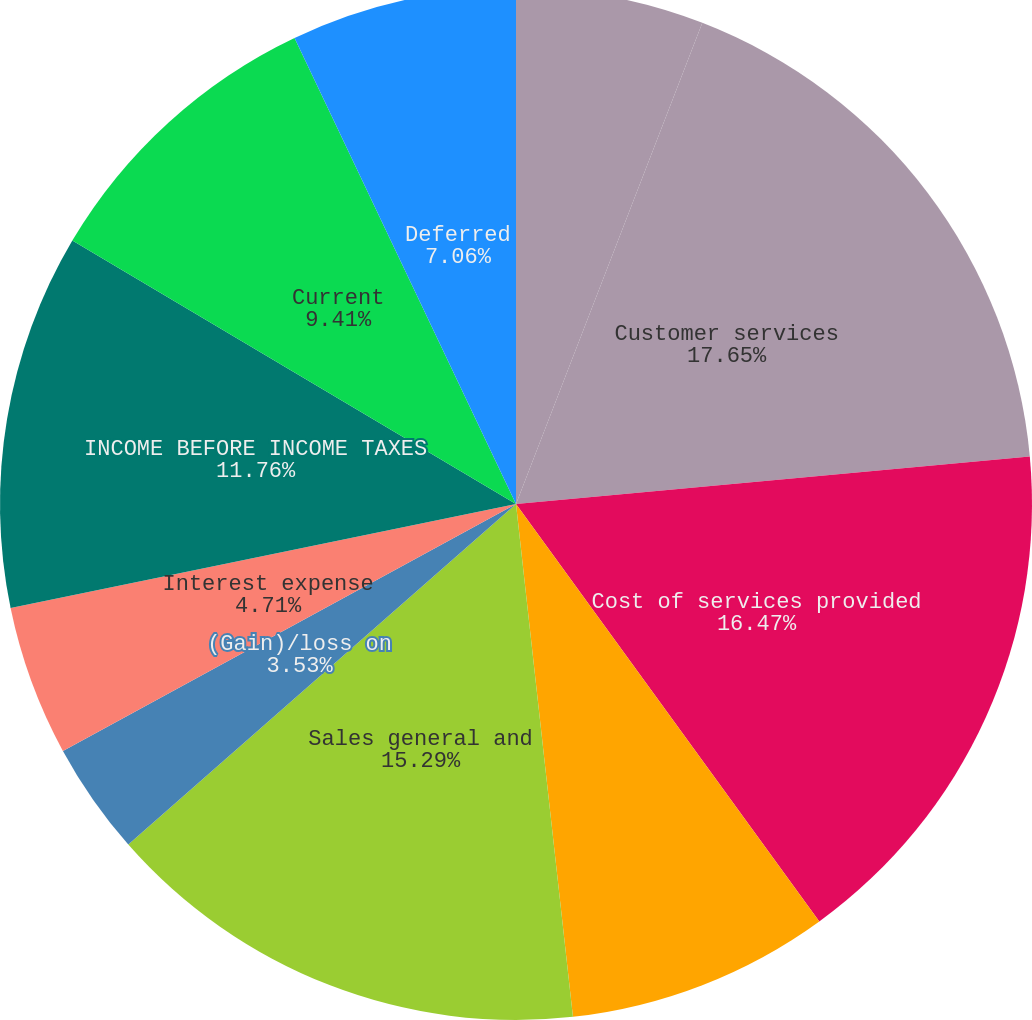<chart> <loc_0><loc_0><loc_500><loc_500><pie_chart><fcel>Years ended December 31 (in<fcel>Customer services<fcel>Cost of services provided<fcel>Depreciation and amortization<fcel>Sales general and<fcel>(Gain)/loss on<fcel>Interest expense<fcel>INCOME BEFORE INCOME TAXES<fcel>Current<fcel>Deferred<nl><fcel>5.88%<fcel>17.65%<fcel>16.47%<fcel>8.24%<fcel>15.29%<fcel>3.53%<fcel>4.71%<fcel>11.76%<fcel>9.41%<fcel>7.06%<nl></chart> 